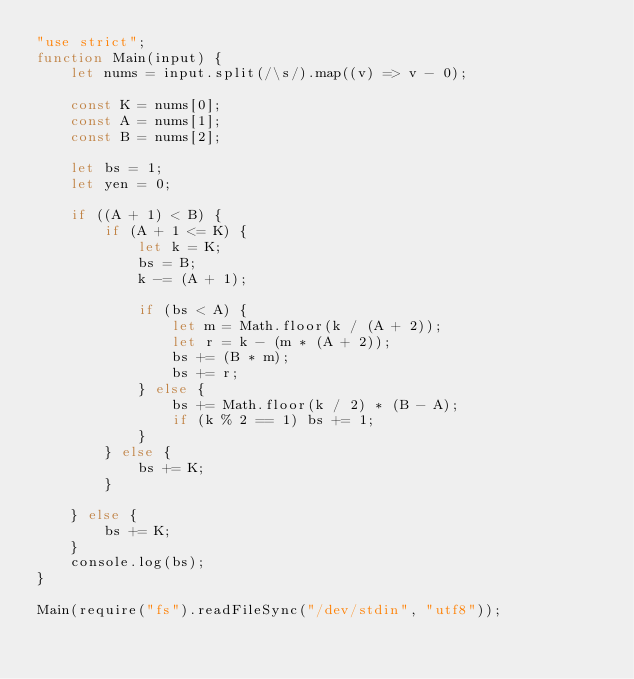Convert code to text. <code><loc_0><loc_0><loc_500><loc_500><_JavaScript_>"use strict";
function Main(input) {
    let nums = input.split(/\s/).map((v) => v - 0);

    const K = nums[0];
    const A = nums[1];
    const B = nums[2];

    let bs = 1;
    let yen = 0;
    
    if ((A + 1) < B) {
        if (A + 1 <= K) {
            let k = K;
            bs = B;
            k -= (A + 1);

            if (bs < A) {
                let m = Math.floor(k / (A + 2));
                let r = k - (m * (A + 2));
                bs += (B * m);
                bs += r;
            } else {
                bs += Math.floor(k / 2) * (B - A);
                if (k % 2 == 1) bs += 1;
            }
        } else {
            bs += K;
        }

    } else {
        bs += K;
    }
    console.log(bs);
}

Main(require("fs").readFileSync("/dev/stdin", "utf8"));
</code> 